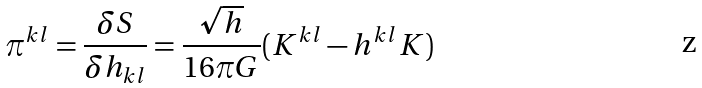<formula> <loc_0><loc_0><loc_500><loc_500>\pi ^ { k l } = \frac { \delta S } { \delta h _ { k l } } = \frac { \sqrt { h } } { 1 6 \pi G } ( K ^ { k l } - h ^ { k l } K )</formula> 